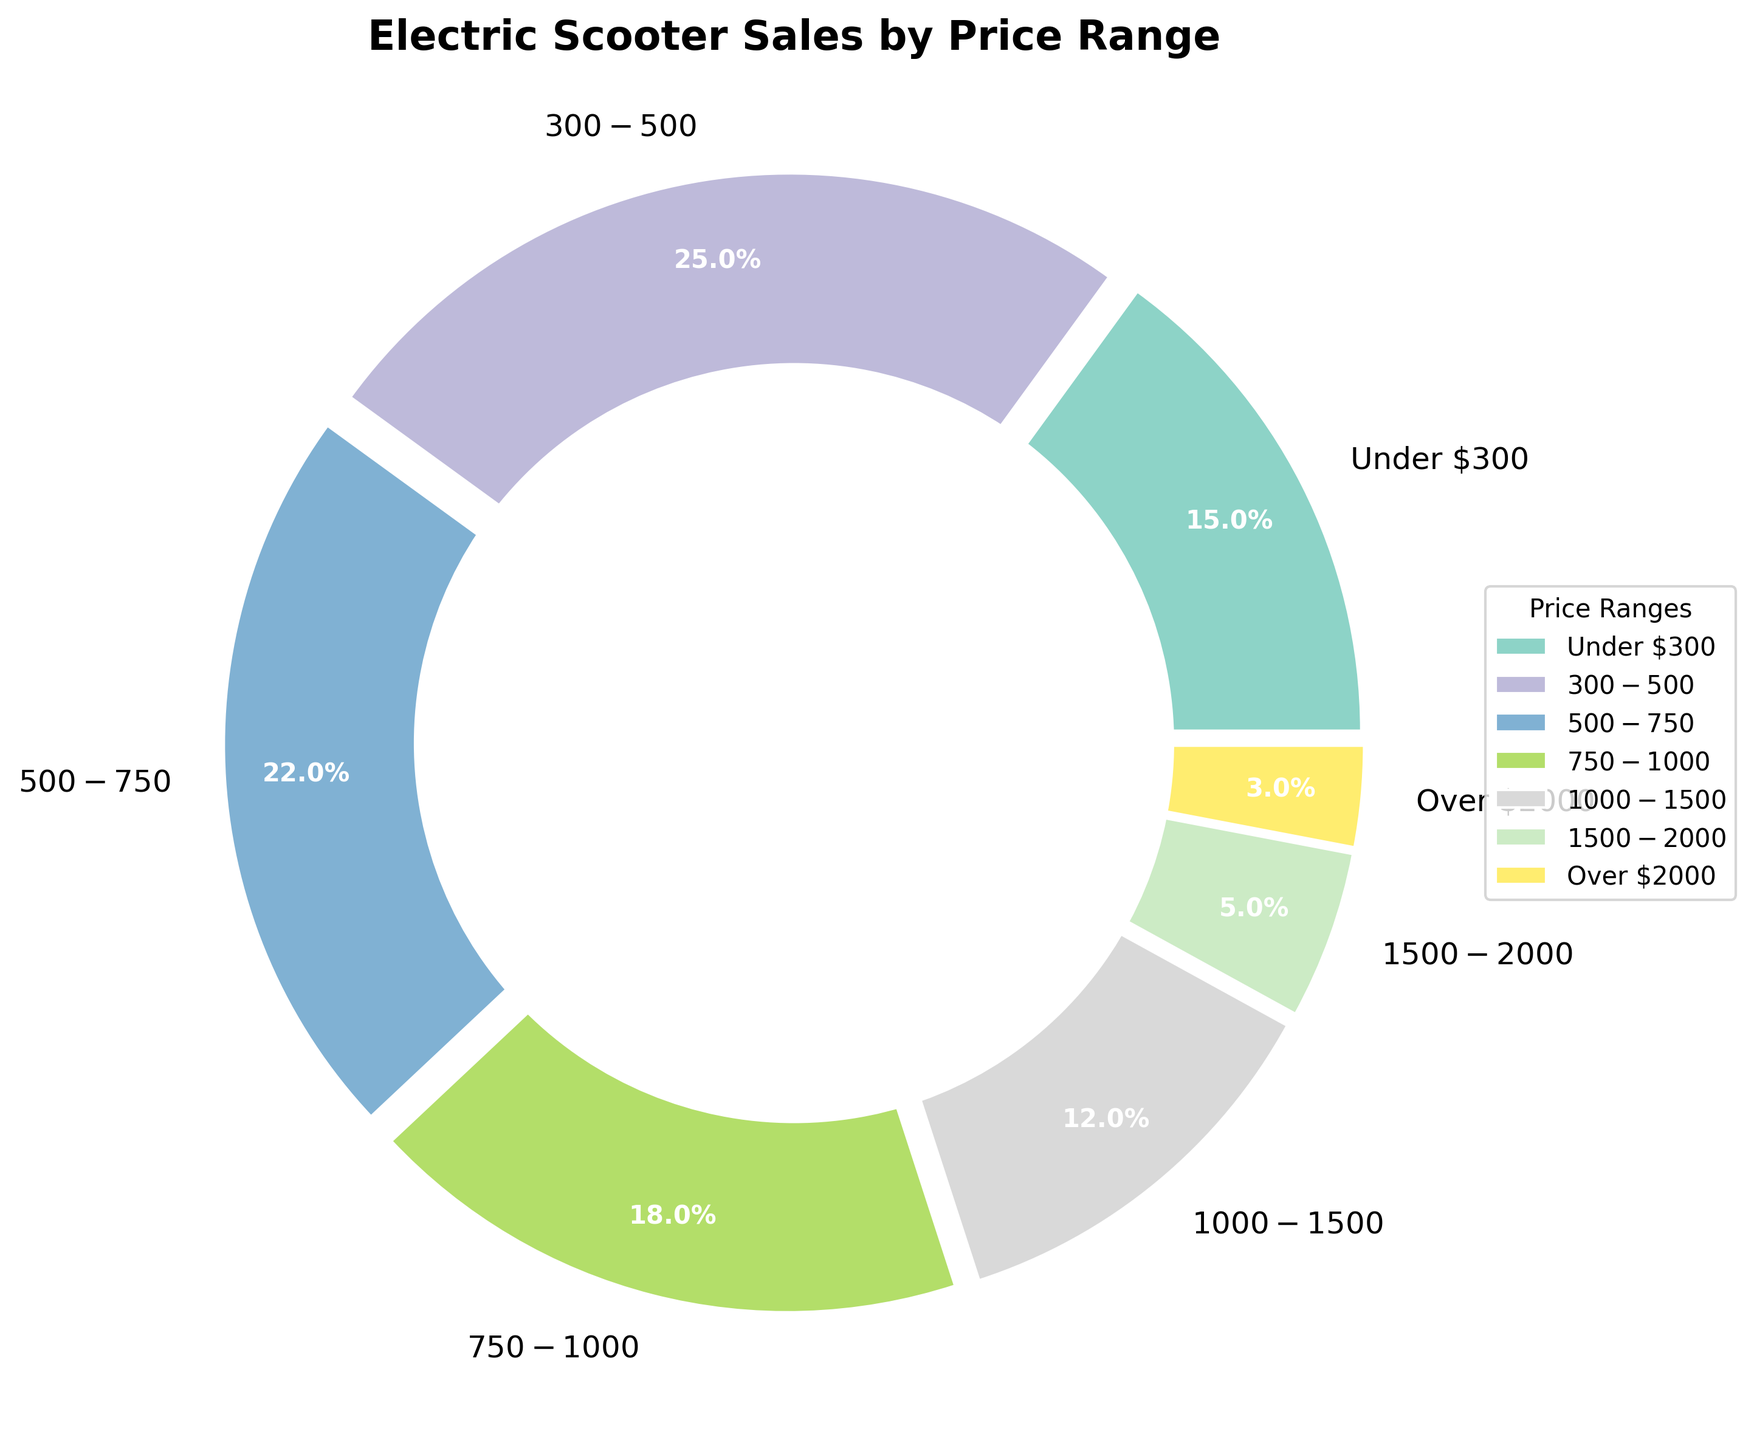What price range has the highest proportion of electric scooter sales? Locate the segment with the largest percentage. The $300-$500 range has the largest slice, indicating it holds the highest proportion at 25%.
Answer: $300-$500 Which price range has the lowest proportion of sales? Identify the segment with the smallest percentage. The "Over $2000" range is the smallest slice, at 3%.
Answer: Over $2000 What is the combined proportion of electric scooter sales for models under $500? Add the proportions for the "Under $300" and "$300-$500" ranges. This results in 15% + 25% = 40%.
Answer: 40% Is the proportion of sales for models priced between $500 and $750 greater than that for models priced between $1000 and $1500? Compare the percentages: $500-$750 is 22% and $1000-$1500 is 12%. Since 22% > 12%, the answer is yes.
Answer: Yes How much larger is the sales proportion for models priced between $300 and $500 compared to those over $2000? Subtract the percentage of the "Over $2000" category from the "$300-$500" category: 25% - 3% = 22%.
Answer: 22% What is the average percentage of sales for models priced between $500 and $2000? Add the percentages of $500-$750 (22%), $750-$1000 (18%), $1000-$1500 (12%), and $1500-$2000 (5%) and divide by 4. (22% + 18% + 12% + 5%) / 4 = 14.25%.
Answer: 14.25% Which price range holds a larger sales proportion: the $750-$1000 range or the $1500-$2000 range? Compare the percentages: the $750-$1000 range is 18% and the $1500-$2000 range is 5%. Since 18% > 5%, the $750-$1000 range holds a larger proportion.
Answer: $750-$1000 Is the total sales proportion for models priced under $750 more than half of the total sales? Calculate the combined proportion for "Under $300," "$300-$500," and "$500-$750." Add these to get 15% + 25% + 22% = 62%, which is more than half of 100%.
Answer: Yes What does the color of the slice representing the $300-$500 price range look like? Observe the pie chart’s legend for the $300-$500 segment. The associated color is the one used in the slice for this price range.
Answer: Natural language description of the color from the plot Which price ranges have a lower sales proportion than models under $300? Identify segments with a lesser percentage than "Under $300" (15%). These ranges are "Over $2000" (3%), "$1500-$2000" (5%), and "$1000-$1500" (12%).
Answer: Over $2000, $1500-$2000, $1000-$1500 